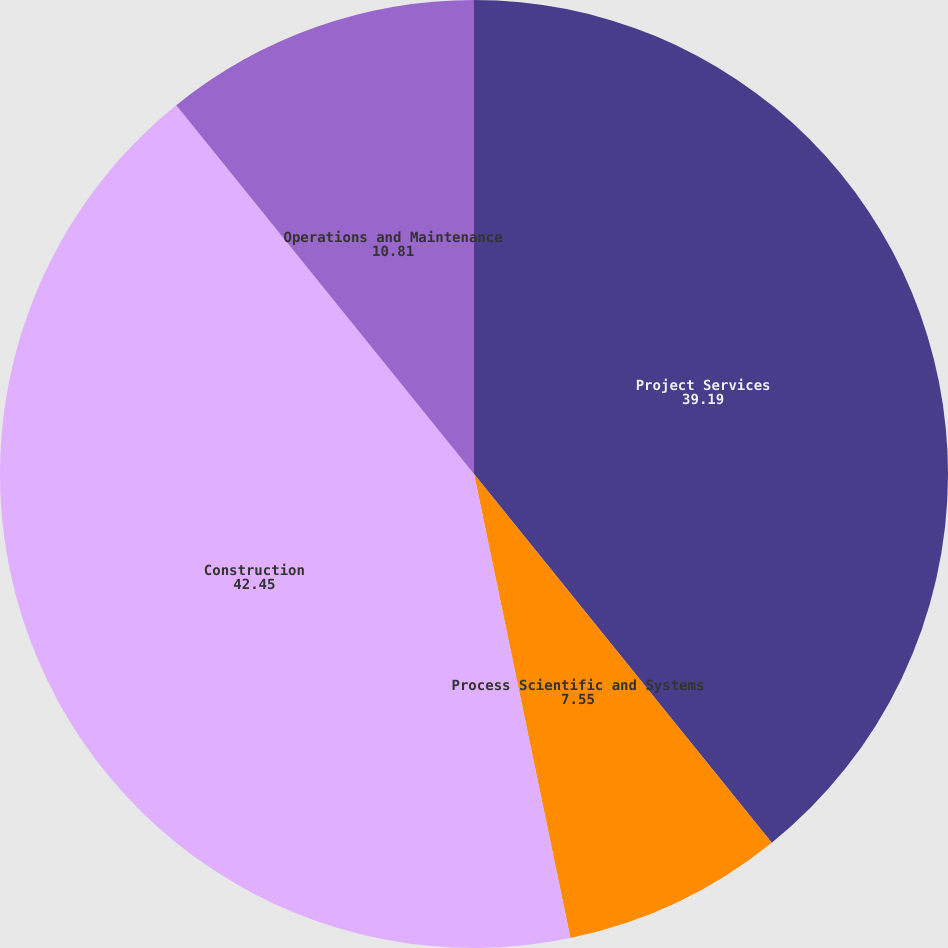Convert chart. <chart><loc_0><loc_0><loc_500><loc_500><pie_chart><fcel>Project Services<fcel>Process Scientific and Systems<fcel>Construction<fcel>Operations and Maintenance<nl><fcel>39.19%<fcel>7.55%<fcel>42.45%<fcel>10.81%<nl></chart> 